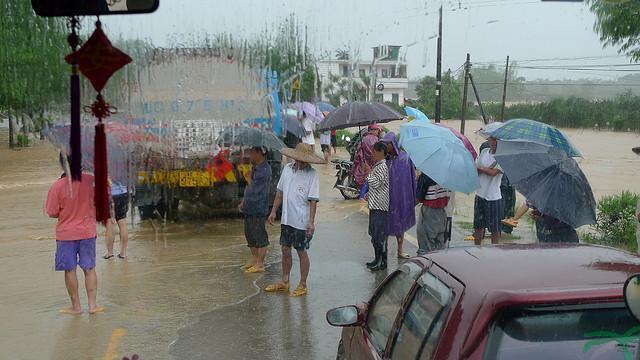What are the people holding the umbrellas trying to avoid?
Indicate the correct choice and explain in the format: 'Answer: answer
Rationale: rationale.'
Options: Rain, sun, snow, wind. Answer: rain.
Rationale: Umbrellas protect people from falling water. 